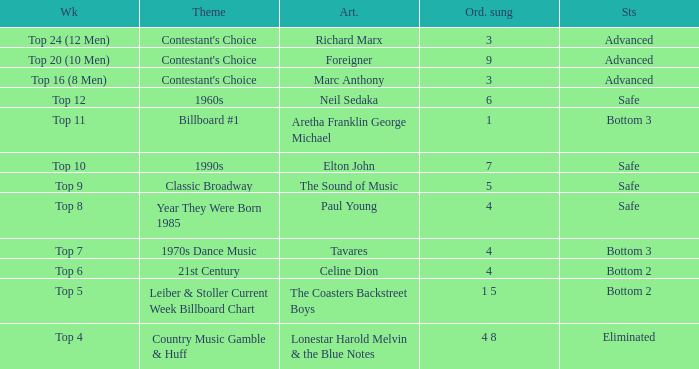What artist's song was performed in the week with theme of Billboard #1? Aretha Franklin George Michael. 